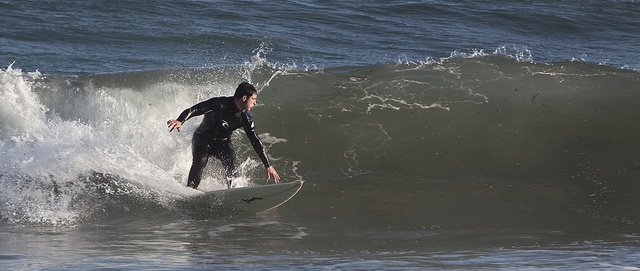Describe the objects in this image and their specific colors. I can see people in blue, black, gray, darkgray, and lightgray tones and surfboard in blue, gray, black, and darkgray tones in this image. 